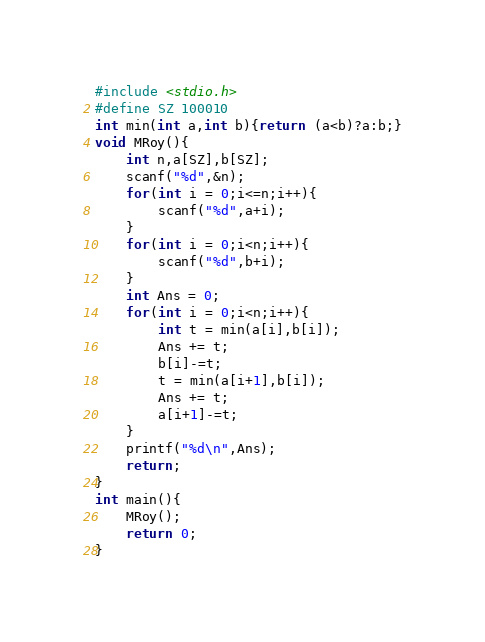<code> <loc_0><loc_0><loc_500><loc_500><_C_>#include <stdio.h>
#define SZ 100010
int min(int a,int b){return (a<b)?a:b;}
void MRoy(){
    int n,a[SZ],b[SZ];
    scanf("%d",&n);
    for(int i = 0;i<=n;i++){
        scanf("%d",a+i);
    }
    for(int i = 0;i<n;i++){
        scanf("%d",b+i);
    }
    int Ans = 0;
    for(int i = 0;i<n;i++){
        int t = min(a[i],b[i]);
        Ans += t;
        b[i]-=t;
        t = min(a[i+1],b[i]);
        Ans += t;
        a[i+1]-=t;
    }
    printf("%d\n",Ans);
    return;
}
int main(){
    MRoy();
    return 0;
}</code> 